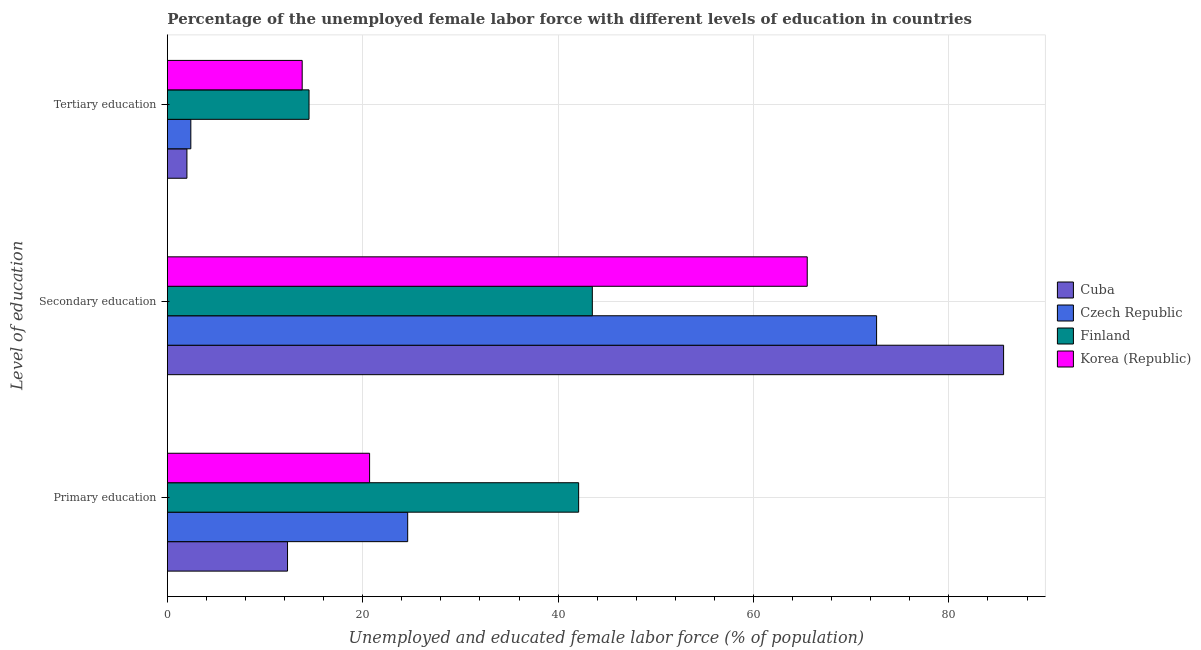Are the number of bars on each tick of the Y-axis equal?
Provide a succinct answer. Yes. How many bars are there on the 3rd tick from the top?
Your answer should be very brief. 4. How many bars are there on the 1st tick from the bottom?
Offer a terse response. 4. What is the label of the 1st group of bars from the top?
Provide a succinct answer. Tertiary education. What is the percentage of female labor force who received primary education in Cuba?
Offer a very short reply. 12.3. Across all countries, what is the maximum percentage of female labor force who received primary education?
Make the answer very short. 42.1. In which country was the percentage of female labor force who received tertiary education minimum?
Make the answer very short. Cuba. What is the total percentage of female labor force who received tertiary education in the graph?
Your response must be concise. 32.7. What is the difference between the percentage of female labor force who received primary education in Finland and that in Czech Republic?
Your answer should be very brief. 17.5. What is the difference between the percentage of female labor force who received secondary education in Korea (Republic) and the percentage of female labor force who received primary education in Cuba?
Make the answer very short. 53.2. What is the average percentage of female labor force who received primary education per country?
Your response must be concise. 24.92. What is the difference between the percentage of female labor force who received secondary education and percentage of female labor force who received tertiary education in Finland?
Provide a short and direct response. 29. What is the ratio of the percentage of female labor force who received primary education in Korea (Republic) to that in Finland?
Provide a short and direct response. 0.49. Is the difference between the percentage of female labor force who received secondary education in Finland and Cuba greater than the difference between the percentage of female labor force who received primary education in Finland and Cuba?
Provide a succinct answer. No. What is the difference between the highest and the second highest percentage of female labor force who received secondary education?
Keep it short and to the point. 13. What is the difference between the highest and the lowest percentage of female labor force who received secondary education?
Keep it short and to the point. 42.1. In how many countries, is the percentage of female labor force who received tertiary education greater than the average percentage of female labor force who received tertiary education taken over all countries?
Give a very brief answer. 2. What does the 3rd bar from the bottom in Primary education represents?
Provide a short and direct response. Finland. Are all the bars in the graph horizontal?
Your answer should be compact. Yes. How many countries are there in the graph?
Your answer should be compact. 4. Are the values on the major ticks of X-axis written in scientific E-notation?
Your answer should be compact. No. Does the graph contain any zero values?
Offer a terse response. No. Where does the legend appear in the graph?
Your response must be concise. Center right. How are the legend labels stacked?
Keep it short and to the point. Vertical. What is the title of the graph?
Provide a succinct answer. Percentage of the unemployed female labor force with different levels of education in countries. What is the label or title of the X-axis?
Keep it short and to the point. Unemployed and educated female labor force (% of population). What is the label or title of the Y-axis?
Provide a succinct answer. Level of education. What is the Unemployed and educated female labor force (% of population) in Cuba in Primary education?
Provide a succinct answer. 12.3. What is the Unemployed and educated female labor force (% of population) of Czech Republic in Primary education?
Offer a terse response. 24.6. What is the Unemployed and educated female labor force (% of population) in Finland in Primary education?
Provide a short and direct response. 42.1. What is the Unemployed and educated female labor force (% of population) in Korea (Republic) in Primary education?
Your response must be concise. 20.7. What is the Unemployed and educated female labor force (% of population) in Cuba in Secondary education?
Ensure brevity in your answer.  85.6. What is the Unemployed and educated female labor force (% of population) of Czech Republic in Secondary education?
Your answer should be compact. 72.6. What is the Unemployed and educated female labor force (% of population) of Finland in Secondary education?
Provide a succinct answer. 43.5. What is the Unemployed and educated female labor force (% of population) of Korea (Republic) in Secondary education?
Offer a very short reply. 65.5. What is the Unemployed and educated female labor force (% of population) of Czech Republic in Tertiary education?
Your response must be concise. 2.4. What is the Unemployed and educated female labor force (% of population) of Korea (Republic) in Tertiary education?
Ensure brevity in your answer.  13.8. Across all Level of education, what is the maximum Unemployed and educated female labor force (% of population) of Cuba?
Offer a very short reply. 85.6. Across all Level of education, what is the maximum Unemployed and educated female labor force (% of population) in Czech Republic?
Make the answer very short. 72.6. Across all Level of education, what is the maximum Unemployed and educated female labor force (% of population) in Finland?
Offer a very short reply. 43.5. Across all Level of education, what is the maximum Unemployed and educated female labor force (% of population) in Korea (Republic)?
Your answer should be compact. 65.5. Across all Level of education, what is the minimum Unemployed and educated female labor force (% of population) in Cuba?
Provide a short and direct response. 2. Across all Level of education, what is the minimum Unemployed and educated female labor force (% of population) in Czech Republic?
Offer a very short reply. 2.4. Across all Level of education, what is the minimum Unemployed and educated female labor force (% of population) of Finland?
Keep it short and to the point. 14.5. Across all Level of education, what is the minimum Unemployed and educated female labor force (% of population) in Korea (Republic)?
Provide a succinct answer. 13.8. What is the total Unemployed and educated female labor force (% of population) of Cuba in the graph?
Offer a very short reply. 99.9. What is the total Unemployed and educated female labor force (% of population) in Czech Republic in the graph?
Offer a very short reply. 99.6. What is the total Unemployed and educated female labor force (% of population) of Finland in the graph?
Provide a succinct answer. 100.1. What is the difference between the Unemployed and educated female labor force (% of population) of Cuba in Primary education and that in Secondary education?
Keep it short and to the point. -73.3. What is the difference between the Unemployed and educated female labor force (% of population) of Czech Republic in Primary education and that in Secondary education?
Make the answer very short. -48. What is the difference between the Unemployed and educated female labor force (% of population) in Korea (Republic) in Primary education and that in Secondary education?
Your response must be concise. -44.8. What is the difference between the Unemployed and educated female labor force (% of population) in Cuba in Primary education and that in Tertiary education?
Offer a very short reply. 10.3. What is the difference between the Unemployed and educated female labor force (% of population) in Czech Republic in Primary education and that in Tertiary education?
Offer a terse response. 22.2. What is the difference between the Unemployed and educated female labor force (% of population) of Finland in Primary education and that in Tertiary education?
Your answer should be very brief. 27.6. What is the difference between the Unemployed and educated female labor force (% of population) in Korea (Republic) in Primary education and that in Tertiary education?
Give a very brief answer. 6.9. What is the difference between the Unemployed and educated female labor force (% of population) in Cuba in Secondary education and that in Tertiary education?
Offer a very short reply. 83.6. What is the difference between the Unemployed and educated female labor force (% of population) of Czech Republic in Secondary education and that in Tertiary education?
Keep it short and to the point. 70.2. What is the difference between the Unemployed and educated female labor force (% of population) in Finland in Secondary education and that in Tertiary education?
Give a very brief answer. 29. What is the difference between the Unemployed and educated female labor force (% of population) of Korea (Republic) in Secondary education and that in Tertiary education?
Your response must be concise. 51.7. What is the difference between the Unemployed and educated female labor force (% of population) of Cuba in Primary education and the Unemployed and educated female labor force (% of population) of Czech Republic in Secondary education?
Your answer should be very brief. -60.3. What is the difference between the Unemployed and educated female labor force (% of population) in Cuba in Primary education and the Unemployed and educated female labor force (% of population) in Finland in Secondary education?
Provide a short and direct response. -31.2. What is the difference between the Unemployed and educated female labor force (% of population) of Cuba in Primary education and the Unemployed and educated female labor force (% of population) of Korea (Republic) in Secondary education?
Offer a very short reply. -53.2. What is the difference between the Unemployed and educated female labor force (% of population) in Czech Republic in Primary education and the Unemployed and educated female labor force (% of population) in Finland in Secondary education?
Provide a short and direct response. -18.9. What is the difference between the Unemployed and educated female labor force (% of population) of Czech Republic in Primary education and the Unemployed and educated female labor force (% of population) of Korea (Republic) in Secondary education?
Make the answer very short. -40.9. What is the difference between the Unemployed and educated female labor force (% of population) of Finland in Primary education and the Unemployed and educated female labor force (% of population) of Korea (Republic) in Secondary education?
Your answer should be very brief. -23.4. What is the difference between the Unemployed and educated female labor force (% of population) of Czech Republic in Primary education and the Unemployed and educated female labor force (% of population) of Finland in Tertiary education?
Your answer should be compact. 10.1. What is the difference between the Unemployed and educated female labor force (% of population) of Finland in Primary education and the Unemployed and educated female labor force (% of population) of Korea (Republic) in Tertiary education?
Your answer should be compact. 28.3. What is the difference between the Unemployed and educated female labor force (% of population) in Cuba in Secondary education and the Unemployed and educated female labor force (% of population) in Czech Republic in Tertiary education?
Your answer should be compact. 83.2. What is the difference between the Unemployed and educated female labor force (% of population) of Cuba in Secondary education and the Unemployed and educated female labor force (% of population) of Finland in Tertiary education?
Your answer should be very brief. 71.1. What is the difference between the Unemployed and educated female labor force (% of population) in Cuba in Secondary education and the Unemployed and educated female labor force (% of population) in Korea (Republic) in Tertiary education?
Your answer should be compact. 71.8. What is the difference between the Unemployed and educated female labor force (% of population) of Czech Republic in Secondary education and the Unemployed and educated female labor force (% of population) of Finland in Tertiary education?
Make the answer very short. 58.1. What is the difference between the Unemployed and educated female labor force (% of population) in Czech Republic in Secondary education and the Unemployed and educated female labor force (% of population) in Korea (Republic) in Tertiary education?
Keep it short and to the point. 58.8. What is the difference between the Unemployed and educated female labor force (% of population) in Finland in Secondary education and the Unemployed and educated female labor force (% of population) in Korea (Republic) in Tertiary education?
Provide a succinct answer. 29.7. What is the average Unemployed and educated female labor force (% of population) in Cuba per Level of education?
Make the answer very short. 33.3. What is the average Unemployed and educated female labor force (% of population) of Czech Republic per Level of education?
Ensure brevity in your answer.  33.2. What is the average Unemployed and educated female labor force (% of population) of Finland per Level of education?
Offer a terse response. 33.37. What is the average Unemployed and educated female labor force (% of population) of Korea (Republic) per Level of education?
Your answer should be very brief. 33.33. What is the difference between the Unemployed and educated female labor force (% of population) of Cuba and Unemployed and educated female labor force (% of population) of Finland in Primary education?
Offer a terse response. -29.8. What is the difference between the Unemployed and educated female labor force (% of population) in Cuba and Unemployed and educated female labor force (% of population) in Korea (Republic) in Primary education?
Provide a short and direct response. -8.4. What is the difference between the Unemployed and educated female labor force (% of population) of Czech Republic and Unemployed and educated female labor force (% of population) of Finland in Primary education?
Give a very brief answer. -17.5. What is the difference between the Unemployed and educated female labor force (% of population) in Czech Republic and Unemployed and educated female labor force (% of population) in Korea (Republic) in Primary education?
Provide a short and direct response. 3.9. What is the difference between the Unemployed and educated female labor force (% of population) in Finland and Unemployed and educated female labor force (% of population) in Korea (Republic) in Primary education?
Your answer should be compact. 21.4. What is the difference between the Unemployed and educated female labor force (% of population) in Cuba and Unemployed and educated female labor force (% of population) in Czech Republic in Secondary education?
Make the answer very short. 13. What is the difference between the Unemployed and educated female labor force (% of population) of Cuba and Unemployed and educated female labor force (% of population) of Finland in Secondary education?
Keep it short and to the point. 42.1. What is the difference between the Unemployed and educated female labor force (% of population) in Cuba and Unemployed and educated female labor force (% of population) in Korea (Republic) in Secondary education?
Provide a short and direct response. 20.1. What is the difference between the Unemployed and educated female labor force (% of population) of Czech Republic and Unemployed and educated female labor force (% of population) of Finland in Secondary education?
Your answer should be very brief. 29.1. What is the difference between the Unemployed and educated female labor force (% of population) in Czech Republic and Unemployed and educated female labor force (% of population) in Korea (Republic) in Secondary education?
Ensure brevity in your answer.  7.1. What is the difference between the Unemployed and educated female labor force (% of population) of Cuba and Unemployed and educated female labor force (% of population) of Czech Republic in Tertiary education?
Your answer should be very brief. -0.4. What is the difference between the Unemployed and educated female labor force (% of population) of Cuba and Unemployed and educated female labor force (% of population) of Finland in Tertiary education?
Provide a short and direct response. -12.5. What is the difference between the Unemployed and educated female labor force (% of population) in Cuba and Unemployed and educated female labor force (% of population) in Korea (Republic) in Tertiary education?
Provide a short and direct response. -11.8. What is the difference between the Unemployed and educated female labor force (% of population) of Czech Republic and Unemployed and educated female labor force (% of population) of Finland in Tertiary education?
Your answer should be compact. -12.1. What is the difference between the Unemployed and educated female labor force (% of population) in Czech Republic and Unemployed and educated female labor force (% of population) in Korea (Republic) in Tertiary education?
Make the answer very short. -11.4. What is the difference between the Unemployed and educated female labor force (% of population) of Finland and Unemployed and educated female labor force (% of population) of Korea (Republic) in Tertiary education?
Make the answer very short. 0.7. What is the ratio of the Unemployed and educated female labor force (% of population) in Cuba in Primary education to that in Secondary education?
Your answer should be very brief. 0.14. What is the ratio of the Unemployed and educated female labor force (% of population) in Czech Republic in Primary education to that in Secondary education?
Your response must be concise. 0.34. What is the ratio of the Unemployed and educated female labor force (% of population) of Finland in Primary education to that in Secondary education?
Keep it short and to the point. 0.97. What is the ratio of the Unemployed and educated female labor force (% of population) of Korea (Republic) in Primary education to that in Secondary education?
Offer a terse response. 0.32. What is the ratio of the Unemployed and educated female labor force (% of population) of Cuba in Primary education to that in Tertiary education?
Offer a terse response. 6.15. What is the ratio of the Unemployed and educated female labor force (% of population) of Czech Republic in Primary education to that in Tertiary education?
Your answer should be very brief. 10.25. What is the ratio of the Unemployed and educated female labor force (% of population) of Finland in Primary education to that in Tertiary education?
Provide a succinct answer. 2.9. What is the ratio of the Unemployed and educated female labor force (% of population) of Cuba in Secondary education to that in Tertiary education?
Provide a short and direct response. 42.8. What is the ratio of the Unemployed and educated female labor force (% of population) of Czech Republic in Secondary education to that in Tertiary education?
Provide a succinct answer. 30.25. What is the ratio of the Unemployed and educated female labor force (% of population) of Finland in Secondary education to that in Tertiary education?
Keep it short and to the point. 3. What is the ratio of the Unemployed and educated female labor force (% of population) of Korea (Republic) in Secondary education to that in Tertiary education?
Your answer should be very brief. 4.75. What is the difference between the highest and the second highest Unemployed and educated female labor force (% of population) in Cuba?
Provide a succinct answer. 73.3. What is the difference between the highest and the second highest Unemployed and educated female labor force (% of population) in Korea (Republic)?
Offer a terse response. 44.8. What is the difference between the highest and the lowest Unemployed and educated female labor force (% of population) in Cuba?
Offer a terse response. 83.6. What is the difference between the highest and the lowest Unemployed and educated female labor force (% of population) in Czech Republic?
Give a very brief answer. 70.2. What is the difference between the highest and the lowest Unemployed and educated female labor force (% of population) of Korea (Republic)?
Your response must be concise. 51.7. 